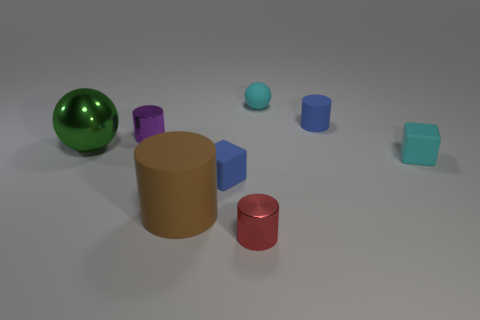Subtract all tiny purple cylinders. How many cylinders are left? 3 Subtract all brown cylinders. How many cylinders are left? 3 Subtract all cubes. How many objects are left? 6 Subtract 3 cylinders. How many cylinders are left? 1 Add 1 tiny blue rubber cylinders. How many objects exist? 9 Subtract all green blocks. Subtract all green cylinders. How many blocks are left? 2 Add 7 small purple objects. How many small purple objects exist? 8 Subtract 0 gray cylinders. How many objects are left? 8 Subtract all gray cubes. How many purple cylinders are left? 1 Subtract all small blue blocks. Subtract all large red matte objects. How many objects are left? 7 